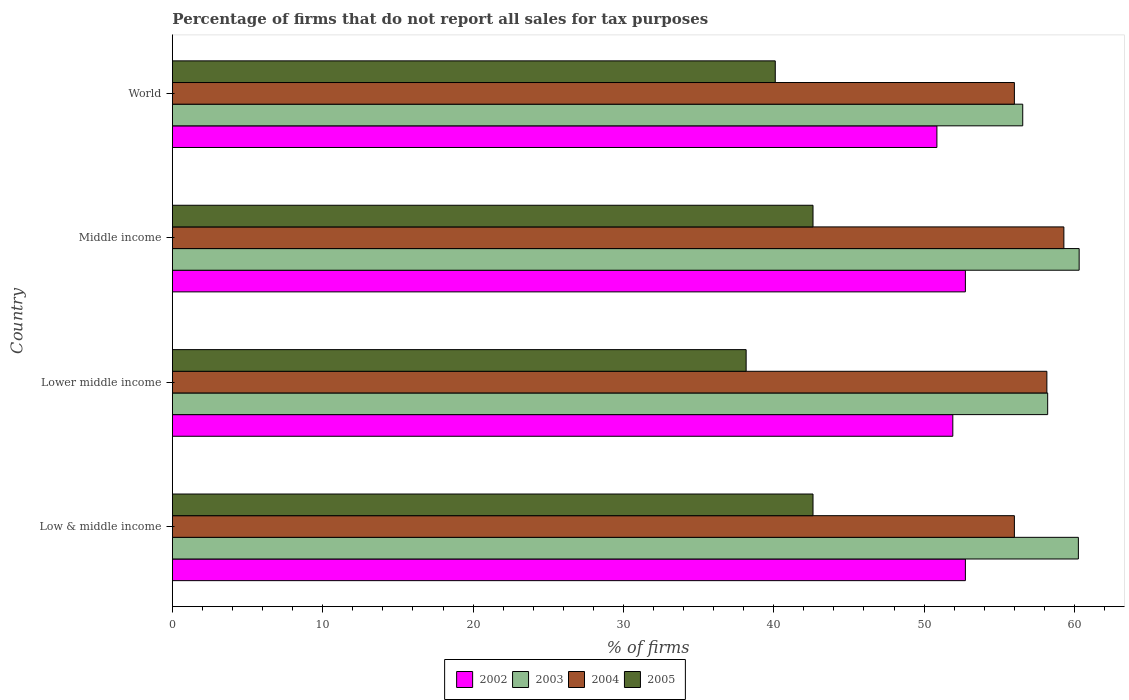How many different coloured bars are there?
Offer a terse response. 4. How many groups of bars are there?
Give a very brief answer. 4. Are the number of bars on each tick of the Y-axis equal?
Give a very brief answer. Yes. How many bars are there on the 2nd tick from the top?
Ensure brevity in your answer.  4. What is the label of the 3rd group of bars from the top?
Make the answer very short. Lower middle income. What is the percentage of firms that do not report all sales for tax purposes in 2002 in Lower middle income?
Offer a very short reply. 51.91. Across all countries, what is the maximum percentage of firms that do not report all sales for tax purposes in 2002?
Provide a succinct answer. 52.75. Across all countries, what is the minimum percentage of firms that do not report all sales for tax purposes in 2005?
Make the answer very short. 38.16. In which country was the percentage of firms that do not report all sales for tax purposes in 2005 minimum?
Your response must be concise. Lower middle income. What is the total percentage of firms that do not report all sales for tax purposes in 2003 in the graph?
Keep it short and to the point. 235.35. What is the difference between the percentage of firms that do not report all sales for tax purposes in 2003 in Lower middle income and that in World?
Provide a short and direct response. 1.66. What is the difference between the percentage of firms that do not report all sales for tax purposes in 2004 in Middle income and the percentage of firms that do not report all sales for tax purposes in 2005 in Low & middle income?
Offer a very short reply. 16.69. What is the average percentage of firms that do not report all sales for tax purposes in 2003 per country?
Give a very brief answer. 58.84. What is the difference between the percentage of firms that do not report all sales for tax purposes in 2004 and percentage of firms that do not report all sales for tax purposes in 2003 in Lower middle income?
Provide a short and direct response. -0.05. What is the ratio of the percentage of firms that do not report all sales for tax purposes in 2002 in Low & middle income to that in World?
Your response must be concise. 1.04. Is the percentage of firms that do not report all sales for tax purposes in 2005 in Low & middle income less than that in Lower middle income?
Provide a short and direct response. No. What is the difference between the highest and the lowest percentage of firms that do not report all sales for tax purposes in 2002?
Make the answer very short. 1.89. In how many countries, is the percentage of firms that do not report all sales for tax purposes in 2004 greater than the average percentage of firms that do not report all sales for tax purposes in 2004 taken over all countries?
Your answer should be very brief. 2. Is the sum of the percentage of firms that do not report all sales for tax purposes in 2005 in Lower middle income and World greater than the maximum percentage of firms that do not report all sales for tax purposes in 2004 across all countries?
Provide a succinct answer. Yes. Is it the case that in every country, the sum of the percentage of firms that do not report all sales for tax purposes in 2004 and percentage of firms that do not report all sales for tax purposes in 2003 is greater than the sum of percentage of firms that do not report all sales for tax purposes in 2002 and percentage of firms that do not report all sales for tax purposes in 2005?
Your answer should be very brief. No. How many bars are there?
Your answer should be very brief. 16. How many countries are there in the graph?
Your answer should be compact. 4. Does the graph contain any zero values?
Your answer should be compact. No. What is the title of the graph?
Offer a very short reply. Percentage of firms that do not report all sales for tax purposes. What is the label or title of the X-axis?
Your answer should be compact. % of firms. What is the % of firms in 2002 in Low & middle income?
Make the answer very short. 52.75. What is the % of firms of 2003 in Low & middle income?
Your response must be concise. 60.26. What is the % of firms of 2004 in Low & middle income?
Offer a very short reply. 56.01. What is the % of firms in 2005 in Low & middle income?
Your answer should be very brief. 42.61. What is the % of firms of 2002 in Lower middle income?
Offer a very short reply. 51.91. What is the % of firms in 2003 in Lower middle income?
Your response must be concise. 58.22. What is the % of firms of 2004 in Lower middle income?
Provide a succinct answer. 58.16. What is the % of firms of 2005 in Lower middle income?
Give a very brief answer. 38.16. What is the % of firms in 2002 in Middle income?
Your response must be concise. 52.75. What is the % of firms in 2003 in Middle income?
Give a very brief answer. 60.31. What is the % of firms in 2004 in Middle income?
Provide a short and direct response. 59.3. What is the % of firms in 2005 in Middle income?
Offer a terse response. 42.61. What is the % of firms in 2002 in World?
Your answer should be very brief. 50.85. What is the % of firms of 2003 in World?
Offer a very short reply. 56.56. What is the % of firms in 2004 in World?
Offer a very short reply. 56.01. What is the % of firms of 2005 in World?
Your answer should be very brief. 40.1. Across all countries, what is the maximum % of firms of 2002?
Your answer should be very brief. 52.75. Across all countries, what is the maximum % of firms of 2003?
Make the answer very short. 60.31. Across all countries, what is the maximum % of firms in 2004?
Keep it short and to the point. 59.3. Across all countries, what is the maximum % of firms in 2005?
Make the answer very short. 42.61. Across all countries, what is the minimum % of firms in 2002?
Make the answer very short. 50.85. Across all countries, what is the minimum % of firms in 2003?
Your response must be concise. 56.56. Across all countries, what is the minimum % of firms in 2004?
Your answer should be very brief. 56.01. Across all countries, what is the minimum % of firms in 2005?
Offer a very short reply. 38.16. What is the total % of firms in 2002 in the graph?
Ensure brevity in your answer.  208.25. What is the total % of firms of 2003 in the graph?
Offer a very short reply. 235.35. What is the total % of firms in 2004 in the graph?
Your answer should be very brief. 229.47. What is the total % of firms of 2005 in the graph?
Give a very brief answer. 163.48. What is the difference between the % of firms in 2002 in Low & middle income and that in Lower middle income?
Offer a very short reply. 0.84. What is the difference between the % of firms of 2003 in Low & middle income and that in Lower middle income?
Your response must be concise. 2.04. What is the difference between the % of firms in 2004 in Low & middle income and that in Lower middle income?
Provide a short and direct response. -2.16. What is the difference between the % of firms of 2005 in Low & middle income and that in Lower middle income?
Make the answer very short. 4.45. What is the difference between the % of firms of 2003 in Low & middle income and that in Middle income?
Ensure brevity in your answer.  -0.05. What is the difference between the % of firms of 2004 in Low & middle income and that in Middle income?
Your answer should be compact. -3.29. What is the difference between the % of firms in 2002 in Low & middle income and that in World?
Make the answer very short. 1.89. What is the difference between the % of firms of 2003 in Low & middle income and that in World?
Provide a short and direct response. 3.7. What is the difference between the % of firms of 2004 in Low & middle income and that in World?
Make the answer very short. 0. What is the difference between the % of firms in 2005 in Low & middle income and that in World?
Offer a very short reply. 2.51. What is the difference between the % of firms of 2002 in Lower middle income and that in Middle income?
Give a very brief answer. -0.84. What is the difference between the % of firms of 2003 in Lower middle income and that in Middle income?
Make the answer very short. -2.09. What is the difference between the % of firms of 2004 in Lower middle income and that in Middle income?
Give a very brief answer. -1.13. What is the difference between the % of firms in 2005 in Lower middle income and that in Middle income?
Provide a short and direct response. -4.45. What is the difference between the % of firms of 2002 in Lower middle income and that in World?
Provide a succinct answer. 1.06. What is the difference between the % of firms of 2003 in Lower middle income and that in World?
Provide a short and direct response. 1.66. What is the difference between the % of firms in 2004 in Lower middle income and that in World?
Your answer should be compact. 2.16. What is the difference between the % of firms in 2005 in Lower middle income and that in World?
Provide a succinct answer. -1.94. What is the difference between the % of firms of 2002 in Middle income and that in World?
Offer a very short reply. 1.89. What is the difference between the % of firms in 2003 in Middle income and that in World?
Offer a very short reply. 3.75. What is the difference between the % of firms in 2004 in Middle income and that in World?
Your answer should be compact. 3.29. What is the difference between the % of firms of 2005 in Middle income and that in World?
Your answer should be compact. 2.51. What is the difference between the % of firms of 2002 in Low & middle income and the % of firms of 2003 in Lower middle income?
Your response must be concise. -5.47. What is the difference between the % of firms of 2002 in Low & middle income and the % of firms of 2004 in Lower middle income?
Your answer should be compact. -5.42. What is the difference between the % of firms in 2002 in Low & middle income and the % of firms in 2005 in Lower middle income?
Offer a very short reply. 14.58. What is the difference between the % of firms in 2003 in Low & middle income and the % of firms in 2004 in Lower middle income?
Provide a succinct answer. 2.1. What is the difference between the % of firms in 2003 in Low & middle income and the % of firms in 2005 in Lower middle income?
Ensure brevity in your answer.  22.1. What is the difference between the % of firms in 2004 in Low & middle income and the % of firms in 2005 in Lower middle income?
Your response must be concise. 17.84. What is the difference between the % of firms in 2002 in Low & middle income and the % of firms in 2003 in Middle income?
Keep it short and to the point. -7.57. What is the difference between the % of firms of 2002 in Low & middle income and the % of firms of 2004 in Middle income?
Give a very brief answer. -6.55. What is the difference between the % of firms of 2002 in Low & middle income and the % of firms of 2005 in Middle income?
Give a very brief answer. 10.13. What is the difference between the % of firms in 2003 in Low & middle income and the % of firms in 2004 in Middle income?
Give a very brief answer. 0.96. What is the difference between the % of firms of 2003 in Low & middle income and the % of firms of 2005 in Middle income?
Keep it short and to the point. 17.65. What is the difference between the % of firms in 2004 in Low & middle income and the % of firms in 2005 in Middle income?
Provide a succinct answer. 13.39. What is the difference between the % of firms of 2002 in Low & middle income and the % of firms of 2003 in World?
Give a very brief answer. -3.81. What is the difference between the % of firms of 2002 in Low & middle income and the % of firms of 2004 in World?
Give a very brief answer. -3.26. What is the difference between the % of firms of 2002 in Low & middle income and the % of firms of 2005 in World?
Offer a very short reply. 12.65. What is the difference between the % of firms of 2003 in Low & middle income and the % of firms of 2004 in World?
Provide a short and direct response. 4.25. What is the difference between the % of firms of 2003 in Low & middle income and the % of firms of 2005 in World?
Make the answer very short. 20.16. What is the difference between the % of firms of 2004 in Low & middle income and the % of firms of 2005 in World?
Your answer should be very brief. 15.91. What is the difference between the % of firms in 2002 in Lower middle income and the % of firms in 2003 in Middle income?
Your response must be concise. -8.4. What is the difference between the % of firms of 2002 in Lower middle income and the % of firms of 2004 in Middle income?
Offer a terse response. -7.39. What is the difference between the % of firms of 2002 in Lower middle income and the % of firms of 2005 in Middle income?
Provide a succinct answer. 9.3. What is the difference between the % of firms in 2003 in Lower middle income and the % of firms in 2004 in Middle income?
Ensure brevity in your answer.  -1.08. What is the difference between the % of firms in 2003 in Lower middle income and the % of firms in 2005 in Middle income?
Make the answer very short. 15.61. What is the difference between the % of firms in 2004 in Lower middle income and the % of firms in 2005 in Middle income?
Your response must be concise. 15.55. What is the difference between the % of firms of 2002 in Lower middle income and the % of firms of 2003 in World?
Provide a succinct answer. -4.65. What is the difference between the % of firms in 2002 in Lower middle income and the % of firms in 2004 in World?
Give a very brief answer. -4.1. What is the difference between the % of firms of 2002 in Lower middle income and the % of firms of 2005 in World?
Provide a succinct answer. 11.81. What is the difference between the % of firms of 2003 in Lower middle income and the % of firms of 2004 in World?
Keep it short and to the point. 2.21. What is the difference between the % of firms of 2003 in Lower middle income and the % of firms of 2005 in World?
Your response must be concise. 18.12. What is the difference between the % of firms of 2004 in Lower middle income and the % of firms of 2005 in World?
Your answer should be very brief. 18.07. What is the difference between the % of firms of 2002 in Middle income and the % of firms of 2003 in World?
Your answer should be compact. -3.81. What is the difference between the % of firms in 2002 in Middle income and the % of firms in 2004 in World?
Your answer should be very brief. -3.26. What is the difference between the % of firms of 2002 in Middle income and the % of firms of 2005 in World?
Ensure brevity in your answer.  12.65. What is the difference between the % of firms of 2003 in Middle income and the % of firms of 2004 in World?
Ensure brevity in your answer.  4.31. What is the difference between the % of firms in 2003 in Middle income and the % of firms in 2005 in World?
Provide a short and direct response. 20.21. What is the difference between the % of firms of 2004 in Middle income and the % of firms of 2005 in World?
Your answer should be very brief. 19.2. What is the average % of firms of 2002 per country?
Make the answer very short. 52.06. What is the average % of firms of 2003 per country?
Offer a terse response. 58.84. What is the average % of firms in 2004 per country?
Provide a short and direct response. 57.37. What is the average % of firms in 2005 per country?
Provide a short and direct response. 40.87. What is the difference between the % of firms in 2002 and % of firms in 2003 in Low & middle income?
Your answer should be compact. -7.51. What is the difference between the % of firms of 2002 and % of firms of 2004 in Low & middle income?
Keep it short and to the point. -3.26. What is the difference between the % of firms of 2002 and % of firms of 2005 in Low & middle income?
Make the answer very short. 10.13. What is the difference between the % of firms of 2003 and % of firms of 2004 in Low & middle income?
Your response must be concise. 4.25. What is the difference between the % of firms in 2003 and % of firms in 2005 in Low & middle income?
Ensure brevity in your answer.  17.65. What is the difference between the % of firms of 2004 and % of firms of 2005 in Low & middle income?
Provide a short and direct response. 13.39. What is the difference between the % of firms in 2002 and % of firms in 2003 in Lower middle income?
Give a very brief answer. -6.31. What is the difference between the % of firms in 2002 and % of firms in 2004 in Lower middle income?
Offer a very short reply. -6.26. What is the difference between the % of firms in 2002 and % of firms in 2005 in Lower middle income?
Your answer should be compact. 13.75. What is the difference between the % of firms in 2003 and % of firms in 2004 in Lower middle income?
Provide a short and direct response. 0.05. What is the difference between the % of firms in 2003 and % of firms in 2005 in Lower middle income?
Give a very brief answer. 20.06. What is the difference between the % of firms of 2004 and % of firms of 2005 in Lower middle income?
Offer a very short reply. 20. What is the difference between the % of firms of 2002 and % of firms of 2003 in Middle income?
Offer a very short reply. -7.57. What is the difference between the % of firms of 2002 and % of firms of 2004 in Middle income?
Offer a very short reply. -6.55. What is the difference between the % of firms in 2002 and % of firms in 2005 in Middle income?
Ensure brevity in your answer.  10.13. What is the difference between the % of firms of 2003 and % of firms of 2004 in Middle income?
Offer a terse response. 1.02. What is the difference between the % of firms in 2003 and % of firms in 2005 in Middle income?
Ensure brevity in your answer.  17.7. What is the difference between the % of firms in 2004 and % of firms in 2005 in Middle income?
Provide a succinct answer. 16.69. What is the difference between the % of firms in 2002 and % of firms in 2003 in World?
Provide a succinct answer. -5.71. What is the difference between the % of firms of 2002 and % of firms of 2004 in World?
Your answer should be compact. -5.15. What is the difference between the % of firms of 2002 and % of firms of 2005 in World?
Offer a very short reply. 10.75. What is the difference between the % of firms in 2003 and % of firms in 2004 in World?
Give a very brief answer. 0.56. What is the difference between the % of firms in 2003 and % of firms in 2005 in World?
Your response must be concise. 16.46. What is the difference between the % of firms in 2004 and % of firms in 2005 in World?
Give a very brief answer. 15.91. What is the ratio of the % of firms of 2002 in Low & middle income to that in Lower middle income?
Provide a short and direct response. 1.02. What is the ratio of the % of firms of 2003 in Low & middle income to that in Lower middle income?
Give a very brief answer. 1.04. What is the ratio of the % of firms in 2004 in Low & middle income to that in Lower middle income?
Give a very brief answer. 0.96. What is the ratio of the % of firms in 2005 in Low & middle income to that in Lower middle income?
Your response must be concise. 1.12. What is the ratio of the % of firms in 2003 in Low & middle income to that in Middle income?
Your answer should be very brief. 1. What is the ratio of the % of firms of 2004 in Low & middle income to that in Middle income?
Offer a very short reply. 0.94. What is the ratio of the % of firms of 2005 in Low & middle income to that in Middle income?
Provide a short and direct response. 1. What is the ratio of the % of firms in 2002 in Low & middle income to that in World?
Ensure brevity in your answer.  1.04. What is the ratio of the % of firms of 2003 in Low & middle income to that in World?
Your response must be concise. 1.07. What is the ratio of the % of firms of 2005 in Low & middle income to that in World?
Ensure brevity in your answer.  1.06. What is the ratio of the % of firms of 2002 in Lower middle income to that in Middle income?
Provide a short and direct response. 0.98. What is the ratio of the % of firms in 2003 in Lower middle income to that in Middle income?
Your response must be concise. 0.97. What is the ratio of the % of firms of 2004 in Lower middle income to that in Middle income?
Make the answer very short. 0.98. What is the ratio of the % of firms of 2005 in Lower middle income to that in Middle income?
Provide a succinct answer. 0.9. What is the ratio of the % of firms in 2002 in Lower middle income to that in World?
Your answer should be very brief. 1.02. What is the ratio of the % of firms in 2003 in Lower middle income to that in World?
Offer a very short reply. 1.03. What is the ratio of the % of firms in 2004 in Lower middle income to that in World?
Provide a succinct answer. 1.04. What is the ratio of the % of firms of 2005 in Lower middle income to that in World?
Keep it short and to the point. 0.95. What is the ratio of the % of firms in 2002 in Middle income to that in World?
Your answer should be very brief. 1.04. What is the ratio of the % of firms in 2003 in Middle income to that in World?
Give a very brief answer. 1.07. What is the ratio of the % of firms in 2004 in Middle income to that in World?
Keep it short and to the point. 1.06. What is the ratio of the % of firms of 2005 in Middle income to that in World?
Ensure brevity in your answer.  1.06. What is the difference between the highest and the second highest % of firms of 2002?
Keep it short and to the point. 0. What is the difference between the highest and the second highest % of firms in 2003?
Keep it short and to the point. 0.05. What is the difference between the highest and the second highest % of firms in 2004?
Keep it short and to the point. 1.13. What is the difference between the highest and the lowest % of firms of 2002?
Provide a short and direct response. 1.89. What is the difference between the highest and the lowest % of firms of 2003?
Offer a terse response. 3.75. What is the difference between the highest and the lowest % of firms of 2004?
Offer a very short reply. 3.29. What is the difference between the highest and the lowest % of firms in 2005?
Your answer should be very brief. 4.45. 